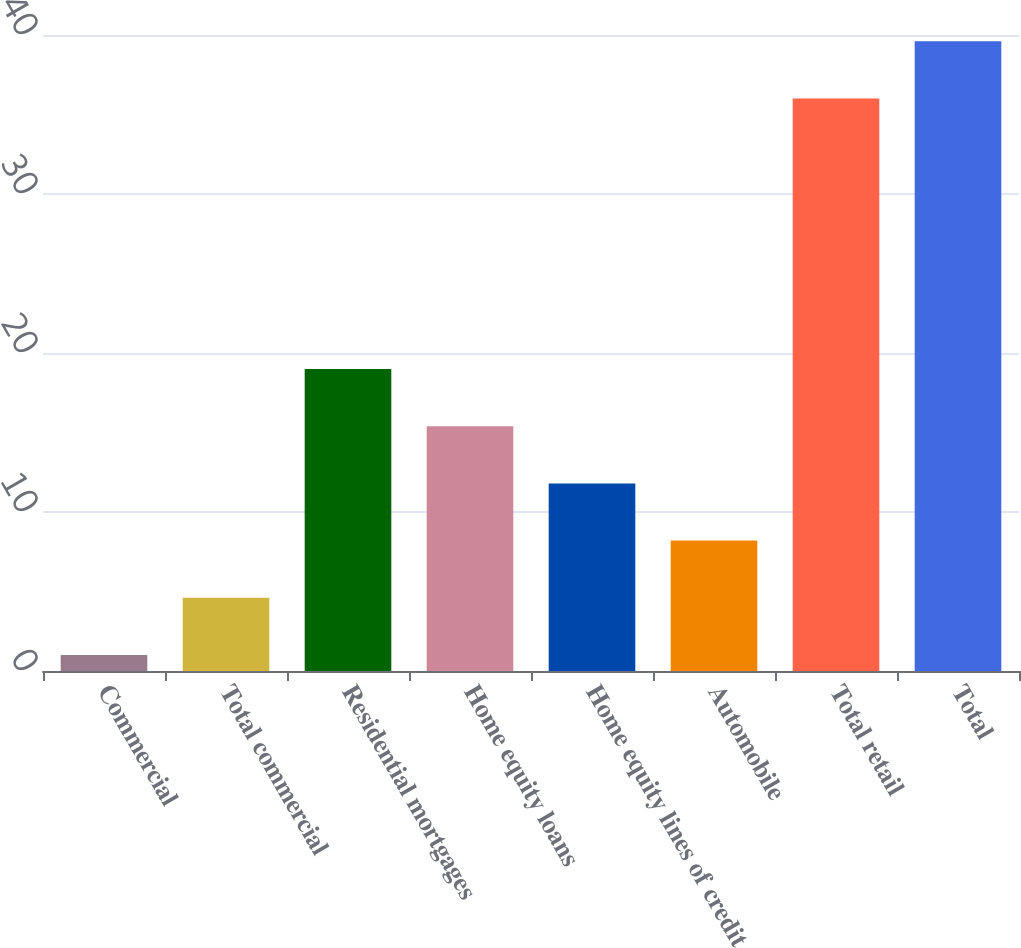Convert chart to OTSL. <chart><loc_0><loc_0><loc_500><loc_500><bar_chart><fcel>Commercial<fcel>Total commercial<fcel>Residential mortgages<fcel>Home equity loans<fcel>Home equity lines of credit<fcel>Automobile<fcel>Total retail<fcel>Total<nl><fcel>1<fcel>4.6<fcel>19<fcel>15.4<fcel>11.8<fcel>8.2<fcel>36<fcel>39.6<nl></chart> 